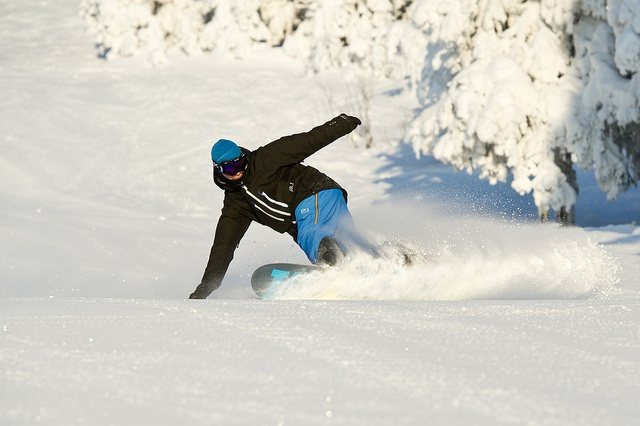Describe the objects in this image and their specific colors. I can see people in lightgray, black, darkgray, teal, and gray tones and snowboard in lightgray, gray, darkgray, and lightblue tones in this image. 